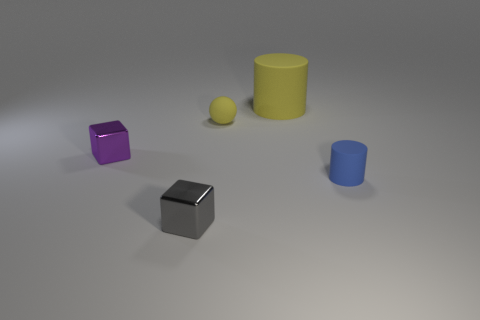Add 4 large yellow cylinders. How many objects exist? 9 Subtract all spheres. How many objects are left? 4 Subtract 0 purple cylinders. How many objects are left? 5 Subtract 1 blocks. How many blocks are left? 1 Subtract all yellow cylinders. Subtract all green balls. How many cylinders are left? 1 Subtract all purple metallic cubes. Subtract all red matte objects. How many objects are left? 4 Add 1 blocks. How many blocks are left? 3 Add 1 gray rubber cubes. How many gray rubber cubes exist? 1 